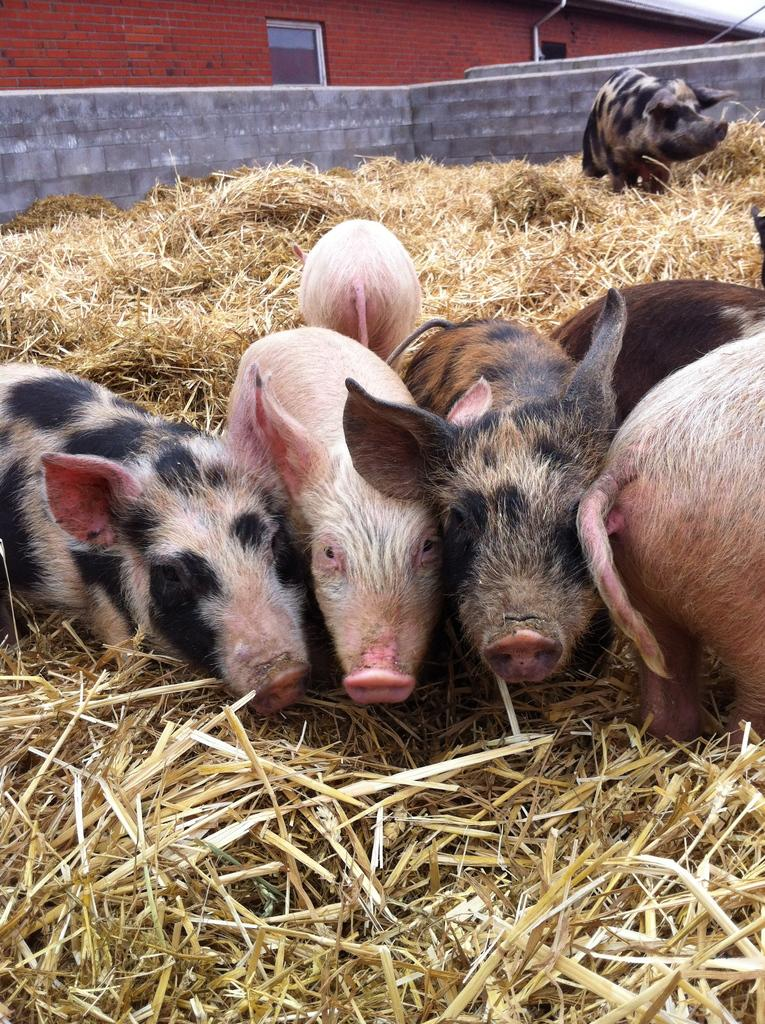What animals are in the center of the image? There are pigs in the center of the image. What type of vegetation is at the bottom of the image? There is dry grass at the bottom of the image. What structures can be seen in the background of the image? There is a house and a wall in the background of the image. What type of nose can be seen on the sack in the image? There is no sack or nose present in the image. What type of advice might the grandmother give in the image? There is no grandmother present in the image, so it is not possible to determine what advice she might give. 